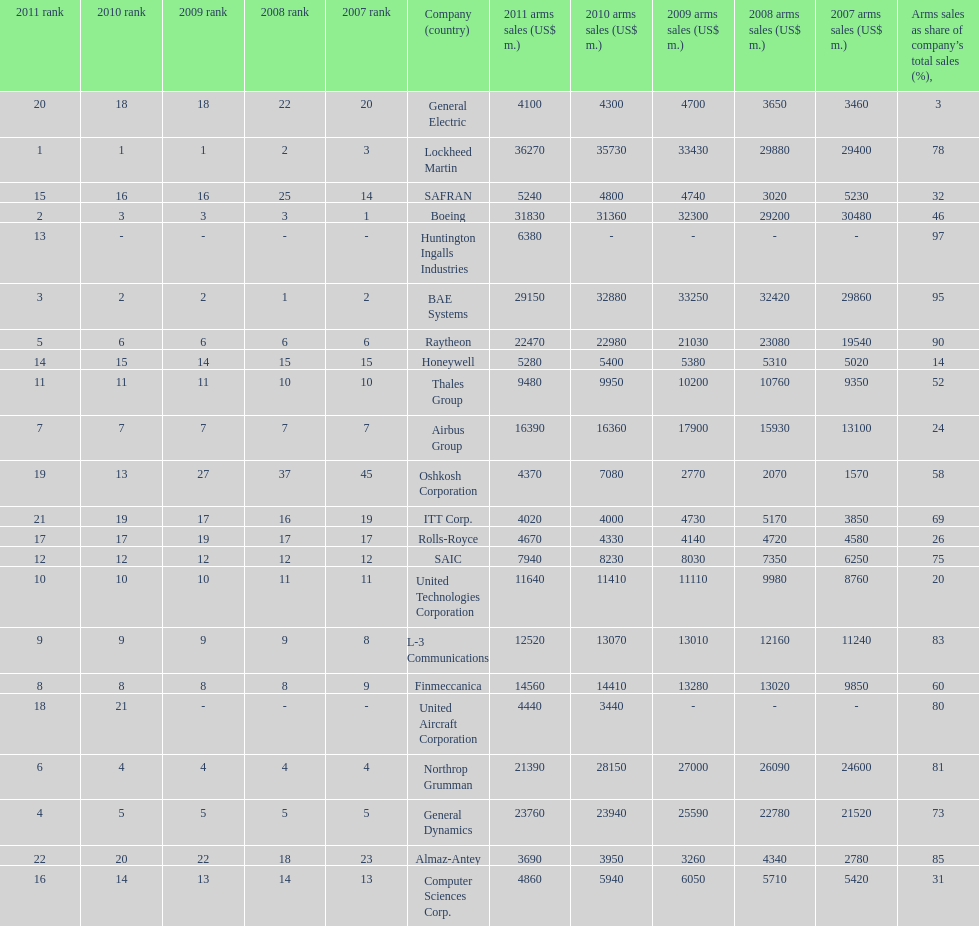Which is the only company to have under 10% arms sales as share of company's total sales? General Electric. 